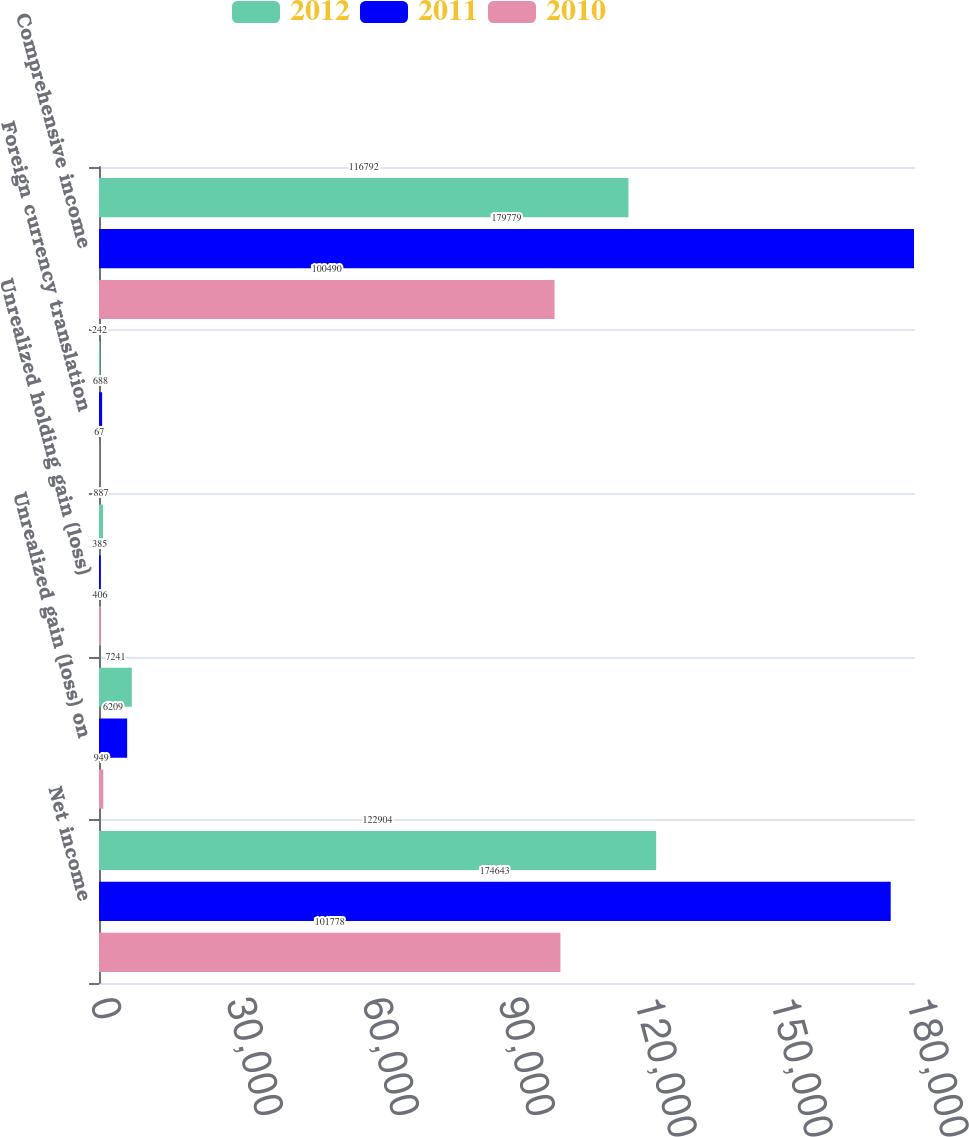<chart> <loc_0><loc_0><loc_500><loc_500><stacked_bar_chart><ecel><fcel>Net income<fcel>Unrealized gain (loss) on<fcel>Unrealized holding gain (loss)<fcel>Foreign currency translation<fcel>Comprehensive income<nl><fcel>2012<fcel>122904<fcel>7241<fcel>887<fcel>242<fcel>116792<nl><fcel>2011<fcel>174643<fcel>6209<fcel>385<fcel>688<fcel>179779<nl><fcel>2010<fcel>101778<fcel>949<fcel>406<fcel>67<fcel>100490<nl></chart> 